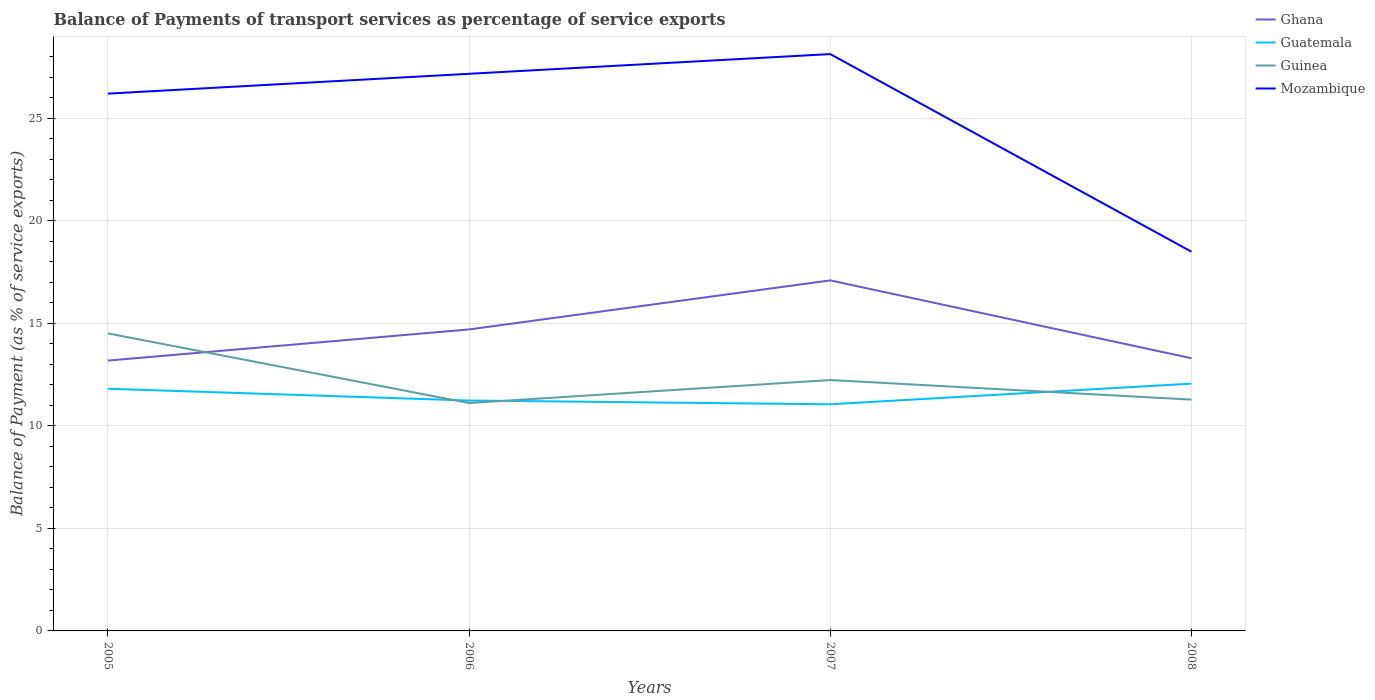Is the number of lines equal to the number of legend labels?
Keep it short and to the point. Yes. Across all years, what is the maximum balance of payments of transport services in Guinea?
Ensure brevity in your answer.  11.12. What is the total balance of payments of transport services in Mozambique in the graph?
Ensure brevity in your answer.  -0.96. What is the difference between the highest and the second highest balance of payments of transport services in Guatemala?
Provide a short and direct response. 1.01. How many lines are there?
Offer a terse response. 4. Does the graph contain grids?
Your answer should be compact. Yes. Where does the legend appear in the graph?
Ensure brevity in your answer.  Top right. What is the title of the graph?
Your answer should be compact. Balance of Payments of transport services as percentage of service exports. Does "Solomon Islands" appear as one of the legend labels in the graph?
Provide a short and direct response. No. What is the label or title of the X-axis?
Your response must be concise. Years. What is the label or title of the Y-axis?
Provide a succinct answer. Balance of Payment (as % of service exports). What is the Balance of Payment (as % of service exports) in Ghana in 2005?
Your answer should be very brief. 13.19. What is the Balance of Payment (as % of service exports) in Guatemala in 2005?
Your response must be concise. 11.81. What is the Balance of Payment (as % of service exports) in Guinea in 2005?
Give a very brief answer. 14.51. What is the Balance of Payment (as % of service exports) in Mozambique in 2005?
Give a very brief answer. 26.21. What is the Balance of Payment (as % of service exports) of Ghana in 2006?
Offer a very short reply. 14.71. What is the Balance of Payment (as % of service exports) in Guatemala in 2006?
Your answer should be compact. 11.24. What is the Balance of Payment (as % of service exports) of Guinea in 2006?
Ensure brevity in your answer.  11.12. What is the Balance of Payment (as % of service exports) in Mozambique in 2006?
Ensure brevity in your answer.  27.18. What is the Balance of Payment (as % of service exports) of Ghana in 2007?
Your response must be concise. 17.1. What is the Balance of Payment (as % of service exports) in Guatemala in 2007?
Provide a succinct answer. 11.06. What is the Balance of Payment (as % of service exports) of Guinea in 2007?
Your answer should be compact. 12.24. What is the Balance of Payment (as % of service exports) in Mozambique in 2007?
Ensure brevity in your answer.  28.14. What is the Balance of Payment (as % of service exports) in Ghana in 2008?
Your response must be concise. 13.3. What is the Balance of Payment (as % of service exports) of Guatemala in 2008?
Keep it short and to the point. 12.06. What is the Balance of Payment (as % of service exports) in Guinea in 2008?
Provide a succinct answer. 11.28. What is the Balance of Payment (as % of service exports) of Mozambique in 2008?
Offer a very short reply. 18.5. Across all years, what is the maximum Balance of Payment (as % of service exports) of Ghana?
Offer a very short reply. 17.1. Across all years, what is the maximum Balance of Payment (as % of service exports) of Guatemala?
Keep it short and to the point. 12.06. Across all years, what is the maximum Balance of Payment (as % of service exports) of Guinea?
Your answer should be very brief. 14.51. Across all years, what is the maximum Balance of Payment (as % of service exports) of Mozambique?
Offer a very short reply. 28.14. Across all years, what is the minimum Balance of Payment (as % of service exports) in Ghana?
Your answer should be very brief. 13.19. Across all years, what is the minimum Balance of Payment (as % of service exports) in Guatemala?
Your response must be concise. 11.06. Across all years, what is the minimum Balance of Payment (as % of service exports) in Guinea?
Your answer should be compact. 11.12. Across all years, what is the minimum Balance of Payment (as % of service exports) of Mozambique?
Ensure brevity in your answer.  18.5. What is the total Balance of Payment (as % of service exports) of Ghana in the graph?
Your answer should be very brief. 58.29. What is the total Balance of Payment (as % of service exports) in Guatemala in the graph?
Offer a terse response. 46.17. What is the total Balance of Payment (as % of service exports) in Guinea in the graph?
Ensure brevity in your answer.  49.15. What is the total Balance of Payment (as % of service exports) of Mozambique in the graph?
Your answer should be compact. 100.02. What is the difference between the Balance of Payment (as % of service exports) of Ghana in 2005 and that in 2006?
Make the answer very short. -1.52. What is the difference between the Balance of Payment (as % of service exports) of Guatemala in 2005 and that in 2006?
Your response must be concise. 0.58. What is the difference between the Balance of Payment (as % of service exports) of Guinea in 2005 and that in 2006?
Your answer should be very brief. 3.4. What is the difference between the Balance of Payment (as % of service exports) of Mozambique in 2005 and that in 2006?
Provide a succinct answer. -0.97. What is the difference between the Balance of Payment (as % of service exports) in Ghana in 2005 and that in 2007?
Offer a very short reply. -3.91. What is the difference between the Balance of Payment (as % of service exports) of Guatemala in 2005 and that in 2007?
Make the answer very short. 0.76. What is the difference between the Balance of Payment (as % of service exports) of Guinea in 2005 and that in 2007?
Offer a terse response. 2.27. What is the difference between the Balance of Payment (as % of service exports) of Mozambique in 2005 and that in 2007?
Ensure brevity in your answer.  -1.93. What is the difference between the Balance of Payment (as % of service exports) in Ghana in 2005 and that in 2008?
Provide a succinct answer. -0.11. What is the difference between the Balance of Payment (as % of service exports) of Guatemala in 2005 and that in 2008?
Offer a terse response. -0.25. What is the difference between the Balance of Payment (as % of service exports) in Guinea in 2005 and that in 2008?
Provide a succinct answer. 3.23. What is the difference between the Balance of Payment (as % of service exports) in Mozambique in 2005 and that in 2008?
Offer a terse response. 7.71. What is the difference between the Balance of Payment (as % of service exports) in Ghana in 2006 and that in 2007?
Your response must be concise. -2.39. What is the difference between the Balance of Payment (as % of service exports) of Guatemala in 2006 and that in 2007?
Make the answer very short. 0.18. What is the difference between the Balance of Payment (as % of service exports) in Guinea in 2006 and that in 2007?
Your answer should be compact. -1.12. What is the difference between the Balance of Payment (as % of service exports) of Mozambique in 2006 and that in 2007?
Make the answer very short. -0.96. What is the difference between the Balance of Payment (as % of service exports) of Ghana in 2006 and that in 2008?
Give a very brief answer. 1.41. What is the difference between the Balance of Payment (as % of service exports) of Guatemala in 2006 and that in 2008?
Your answer should be compact. -0.82. What is the difference between the Balance of Payment (as % of service exports) of Guinea in 2006 and that in 2008?
Make the answer very short. -0.17. What is the difference between the Balance of Payment (as % of service exports) of Mozambique in 2006 and that in 2008?
Provide a succinct answer. 8.68. What is the difference between the Balance of Payment (as % of service exports) of Ghana in 2007 and that in 2008?
Keep it short and to the point. 3.8. What is the difference between the Balance of Payment (as % of service exports) in Guatemala in 2007 and that in 2008?
Provide a short and direct response. -1.01. What is the difference between the Balance of Payment (as % of service exports) in Guinea in 2007 and that in 2008?
Provide a short and direct response. 0.96. What is the difference between the Balance of Payment (as % of service exports) in Mozambique in 2007 and that in 2008?
Ensure brevity in your answer.  9.64. What is the difference between the Balance of Payment (as % of service exports) in Ghana in 2005 and the Balance of Payment (as % of service exports) in Guatemala in 2006?
Your answer should be very brief. 1.95. What is the difference between the Balance of Payment (as % of service exports) in Ghana in 2005 and the Balance of Payment (as % of service exports) in Guinea in 2006?
Provide a succinct answer. 2.07. What is the difference between the Balance of Payment (as % of service exports) of Ghana in 2005 and the Balance of Payment (as % of service exports) of Mozambique in 2006?
Provide a succinct answer. -13.99. What is the difference between the Balance of Payment (as % of service exports) in Guatemala in 2005 and the Balance of Payment (as % of service exports) in Guinea in 2006?
Make the answer very short. 0.7. What is the difference between the Balance of Payment (as % of service exports) of Guatemala in 2005 and the Balance of Payment (as % of service exports) of Mozambique in 2006?
Provide a succinct answer. -15.36. What is the difference between the Balance of Payment (as % of service exports) in Guinea in 2005 and the Balance of Payment (as % of service exports) in Mozambique in 2006?
Offer a terse response. -12.66. What is the difference between the Balance of Payment (as % of service exports) in Ghana in 2005 and the Balance of Payment (as % of service exports) in Guatemala in 2007?
Provide a short and direct response. 2.13. What is the difference between the Balance of Payment (as % of service exports) in Ghana in 2005 and the Balance of Payment (as % of service exports) in Guinea in 2007?
Your answer should be compact. 0.95. What is the difference between the Balance of Payment (as % of service exports) in Ghana in 2005 and the Balance of Payment (as % of service exports) in Mozambique in 2007?
Your answer should be compact. -14.95. What is the difference between the Balance of Payment (as % of service exports) of Guatemala in 2005 and the Balance of Payment (as % of service exports) of Guinea in 2007?
Offer a terse response. -0.42. What is the difference between the Balance of Payment (as % of service exports) in Guatemala in 2005 and the Balance of Payment (as % of service exports) in Mozambique in 2007?
Make the answer very short. -16.32. What is the difference between the Balance of Payment (as % of service exports) in Guinea in 2005 and the Balance of Payment (as % of service exports) in Mozambique in 2007?
Keep it short and to the point. -13.62. What is the difference between the Balance of Payment (as % of service exports) in Ghana in 2005 and the Balance of Payment (as % of service exports) in Guatemala in 2008?
Provide a succinct answer. 1.12. What is the difference between the Balance of Payment (as % of service exports) in Ghana in 2005 and the Balance of Payment (as % of service exports) in Guinea in 2008?
Give a very brief answer. 1.9. What is the difference between the Balance of Payment (as % of service exports) in Ghana in 2005 and the Balance of Payment (as % of service exports) in Mozambique in 2008?
Provide a succinct answer. -5.31. What is the difference between the Balance of Payment (as % of service exports) in Guatemala in 2005 and the Balance of Payment (as % of service exports) in Guinea in 2008?
Your answer should be compact. 0.53. What is the difference between the Balance of Payment (as % of service exports) in Guatemala in 2005 and the Balance of Payment (as % of service exports) in Mozambique in 2008?
Ensure brevity in your answer.  -6.68. What is the difference between the Balance of Payment (as % of service exports) in Guinea in 2005 and the Balance of Payment (as % of service exports) in Mozambique in 2008?
Provide a succinct answer. -3.98. What is the difference between the Balance of Payment (as % of service exports) in Ghana in 2006 and the Balance of Payment (as % of service exports) in Guatemala in 2007?
Provide a short and direct response. 3.65. What is the difference between the Balance of Payment (as % of service exports) of Ghana in 2006 and the Balance of Payment (as % of service exports) of Guinea in 2007?
Your response must be concise. 2.47. What is the difference between the Balance of Payment (as % of service exports) of Ghana in 2006 and the Balance of Payment (as % of service exports) of Mozambique in 2007?
Keep it short and to the point. -13.43. What is the difference between the Balance of Payment (as % of service exports) in Guatemala in 2006 and the Balance of Payment (as % of service exports) in Guinea in 2007?
Your response must be concise. -1. What is the difference between the Balance of Payment (as % of service exports) of Guatemala in 2006 and the Balance of Payment (as % of service exports) of Mozambique in 2007?
Your answer should be compact. -16.9. What is the difference between the Balance of Payment (as % of service exports) in Guinea in 2006 and the Balance of Payment (as % of service exports) in Mozambique in 2007?
Ensure brevity in your answer.  -17.02. What is the difference between the Balance of Payment (as % of service exports) in Ghana in 2006 and the Balance of Payment (as % of service exports) in Guatemala in 2008?
Ensure brevity in your answer.  2.64. What is the difference between the Balance of Payment (as % of service exports) of Ghana in 2006 and the Balance of Payment (as % of service exports) of Guinea in 2008?
Provide a short and direct response. 3.42. What is the difference between the Balance of Payment (as % of service exports) of Ghana in 2006 and the Balance of Payment (as % of service exports) of Mozambique in 2008?
Provide a short and direct response. -3.79. What is the difference between the Balance of Payment (as % of service exports) of Guatemala in 2006 and the Balance of Payment (as % of service exports) of Guinea in 2008?
Offer a terse response. -0.04. What is the difference between the Balance of Payment (as % of service exports) of Guatemala in 2006 and the Balance of Payment (as % of service exports) of Mozambique in 2008?
Ensure brevity in your answer.  -7.26. What is the difference between the Balance of Payment (as % of service exports) of Guinea in 2006 and the Balance of Payment (as % of service exports) of Mozambique in 2008?
Your response must be concise. -7.38. What is the difference between the Balance of Payment (as % of service exports) in Ghana in 2007 and the Balance of Payment (as % of service exports) in Guatemala in 2008?
Your response must be concise. 5.04. What is the difference between the Balance of Payment (as % of service exports) of Ghana in 2007 and the Balance of Payment (as % of service exports) of Guinea in 2008?
Keep it short and to the point. 5.82. What is the difference between the Balance of Payment (as % of service exports) in Ghana in 2007 and the Balance of Payment (as % of service exports) in Mozambique in 2008?
Give a very brief answer. -1.4. What is the difference between the Balance of Payment (as % of service exports) in Guatemala in 2007 and the Balance of Payment (as % of service exports) in Guinea in 2008?
Your answer should be compact. -0.23. What is the difference between the Balance of Payment (as % of service exports) of Guatemala in 2007 and the Balance of Payment (as % of service exports) of Mozambique in 2008?
Give a very brief answer. -7.44. What is the difference between the Balance of Payment (as % of service exports) of Guinea in 2007 and the Balance of Payment (as % of service exports) of Mozambique in 2008?
Make the answer very short. -6.26. What is the average Balance of Payment (as % of service exports) in Ghana per year?
Ensure brevity in your answer.  14.57. What is the average Balance of Payment (as % of service exports) of Guatemala per year?
Provide a short and direct response. 11.54. What is the average Balance of Payment (as % of service exports) in Guinea per year?
Offer a very short reply. 12.29. What is the average Balance of Payment (as % of service exports) of Mozambique per year?
Make the answer very short. 25.01. In the year 2005, what is the difference between the Balance of Payment (as % of service exports) in Ghana and Balance of Payment (as % of service exports) in Guatemala?
Your answer should be compact. 1.37. In the year 2005, what is the difference between the Balance of Payment (as % of service exports) in Ghana and Balance of Payment (as % of service exports) in Guinea?
Your response must be concise. -1.33. In the year 2005, what is the difference between the Balance of Payment (as % of service exports) in Ghana and Balance of Payment (as % of service exports) in Mozambique?
Make the answer very short. -13.02. In the year 2005, what is the difference between the Balance of Payment (as % of service exports) in Guatemala and Balance of Payment (as % of service exports) in Guinea?
Provide a succinct answer. -2.7. In the year 2005, what is the difference between the Balance of Payment (as % of service exports) in Guatemala and Balance of Payment (as % of service exports) in Mozambique?
Your answer should be compact. -14.4. In the year 2005, what is the difference between the Balance of Payment (as % of service exports) in Guinea and Balance of Payment (as % of service exports) in Mozambique?
Your response must be concise. -11.7. In the year 2006, what is the difference between the Balance of Payment (as % of service exports) in Ghana and Balance of Payment (as % of service exports) in Guatemala?
Keep it short and to the point. 3.47. In the year 2006, what is the difference between the Balance of Payment (as % of service exports) in Ghana and Balance of Payment (as % of service exports) in Guinea?
Give a very brief answer. 3.59. In the year 2006, what is the difference between the Balance of Payment (as % of service exports) of Ghana and Balance of Payment (as % of service exports) of Mozambique?
Make the answer very short. -12.47. In the year 2006, what is the difference between the Balance of Payment (as % of service exports) in Guatemala and Balance of Payment (as % of service exports) in Guinea?
Provide a short and direct response. 0.12. In the year 2006, what is the difference between the Balance of Payment (as % of service exports) of Guatemala and Balance of Payment (as % of service exports) of Mozambique?
Your answer should be very brief. -15.94. In the year 2006, what is the difference between the Balance of Payment (as % of service exports) in Guinea and Balance of Payment (as % of service exports) in Mozambique?
Give a very brief answer. -16.06. In the year 2007, what is the difference between the Balance of Payment (as % of service exports) in Ghana and Balance of Payment (as % of service exports) in Guatemala?
Provide a succinct answer. 6.04. In the year 2007, what is the difference between the Balance of Payment (as % of service exports) in Ghana and Balance of Payment (as % of service exports) in Guinea?
Provide a succinct answer. 4.86. In the year 2007, what is the difference between the Balance of Payment (as % of service exports) in Ghana and Balance of Payment (as % of service exports) in Mozambique?
Make the answer very short. -11.04. In the year 2007, what is the difference between the Balance of Payment (as % of service exports) of Guatemala and Balance of Payment (as % of service exports) of Guinea?
Your response must be concise. -1.18. In the year 2007, what is the difference between the Balance of Payment (as % of service exports) in Guatemala and Balance of Payment (as % of service exports) in Mozambique?
Your response must be concise. -17.08. In the year 2007, what is the difference between the Balance of Payment (as % of service exports) of Guinea and Balance of Payment (as % of service exports) of Mozambique?
Provide a succinct answer. -15.9. In the year 2008, what is the difference between the Balance of Payment (as % of service exports) of Ghana and Balance of Payment (as % of service exports) of Guatemala?
Your answer should be very brief. 1.24. In the year 2008, what is the difference between the Balance of Payment (as % of service exports) of Ghana and Balance of Payment (as % of service exports) of Guinea?
Your answer should be very brief. 2.02. In the year 2008, what is the difference between the Balance of Payment (as % of service exports) of Ghana and Balance of Payment (as % of service exports) of Mozambique?
Offer a very short reply. -5.2. In the year 2008, what is the difference between the Balance of Payment (as % of service exports) of Guatemala and Balance of Payment (as % of service exports) of Guinea?
Offer a terse response. 0.78. In the year 2008, what is the difference between the Balance of Payment (as % of service exports) of Guatemala and Balance of Payment (as % of service exports) of Mozambique?
Ensure brevity in your answer.  -6.44. In the year 2008, what is the difference between the Balance of Payment (as % of service exports) of Guinea and Balance of Payment (as % of service exports) of Mozambique?
Offer a terse response. -7.21. What is the ratio of the Balance of Payment (as % of service exports) of Ghana in 2005 to that in 2006?
Your answer should be compact. 0.9. What is the ratio of the Balance of Payment (as % of service exports) in Guatemala in 2005 to that in 2006?
Provide a succinct answer. 1.05. What is the ratio of the Balance of Payment (as % of service exports) in Guinea in 2005 to that in 2006?
Keep it short and to the point. 1.31. What is the ratio of the Balance of Payment (as % of service exports) in Mozambique in 2005 to that in 2006?
Offer a very short reply. 0.96. What is the ratio of the Balance of Payment (as % of service exports) in Ghana in 2005 to that in 2007?
Provide a succinct answer. 0.77. What is the ratio of the Balance of Payment (as % of service exports) in Guatemala in 2005 to that in 2007?
Give a very brief answer. 1.07. What is the ratio of the Balance of Payment (as % of service exports) in Guinea in 2005 to that in 2007?
Provide a short and direct response. 1.19. What is the ratio of the Balance of Payment (as % of service exports) in Mozambique in 2005 to that in 2007?
Make the answer very short. 0.93. What is the ratio of the Balance of Payment (as % of service exports) of Ghana in 2005 to that in 2008?
Offer a very short reply. 0.99. What is the ratio of the Balance of Payment (as % of service exports) in Guatemala in 2005 to that in 2008?
Offer a very short reply. 0.98. What is the ratio of the Balance of Payment (as % of service exports) of Guinea in 2005 to that in 2008?
Provide a short and direct response. 1.29. What is the ratio of the Balance of Payment (as % of service exports) in Mozambique in 2005 to that in 2008?
Your response must be concise. 1.42. What is the ratio of the Balance of Payment (as % of service exports) in Ghana in 2006 to that in 2007?
Make the answer very short. 0.86. What is the ratio of the Balance of Payment (as % of service exports) in Guatemala in 2006 to that in 2007?
Give a very brief answer. 1.02. What is the ratio of the Balance of Payment (as % of service exports) of Guinea in 2006 to that in 2007?
Your answer should be compact. 0.91. What is the ratio of the Balance of Payment (as % of service exports) of Mozambique in 2006 to that in 2007?
Keep it short and to the point. 0.97. What is the ratio of the Balance of Payment (as % of service exports) of Ghana in 2006 to that in 2008?
Offer a terse response. 1.11. What is the ratio of the Balance of Payment (as % of service exports) of Guatemala in 2006 to that in 2008?
Keep it short and to the point. 0.93. What is the ratio of the Balance of Payment (as % of service exports) in Guinea in 2006 to that in 2008?
Keep it short and to the point. 0.99. What is the ratio of the Balance of Payment (as % of service exports) of Mozambique in 2006 to that in 2008?
Provide a succinct answer. 1.47. What is the ratio of the Balance of Payment (as % of service exports) of Ghana in 2007 to that in 2008?
Provide a succinct answer. 1.29. What is the ratio of the Balance of Payment (as % of service exports) in Guatemala in 2007 to that in 2008?
Offer a very short reply. 0.92. What is the ratio of the Balance of Payment (as % of service exports) in Guinea in 2007 to that in 2008?
Your answer should be very brief. 1.08. What is the ratio of the Balance of Payment (as % of service exports) of Mozambique in 2007 to that in 2008?
Give a very brief answer. 1.52. What is the difference between the highest and the second highest Balance of Payment (as % of service exports) of Ghana?
Keep it short and to the point. 2.39. What is the difference between the highest and the second highest Balance of Payment (as % of service exports) in Guatemala?
Provide a short and direct response. 0.25. What is the difference between the highest and the second highest Balance of Payment (as % of service exports) of Guinea?
Ensure brevity in your answer.  2.27. What is the difference between the highest and the second highest Balance of Payment (as % of service exports) of Mozambique?
Your answer should be compact. 0.96. What is the difference between the highest and the lowest Balance of Payment (as % of service exports) in Ghana?
Ensure brevity in your answer.  3.91. What is the difference between the highest and the lowest Balance of Payment (as % of service exports) in Guinea?
Give a very brief answer. 3.4. What is the difference between the highest and the lowest Balance of Payment (as % of service exports) in Mozambique?
Give a very brief answer. 9.64. 